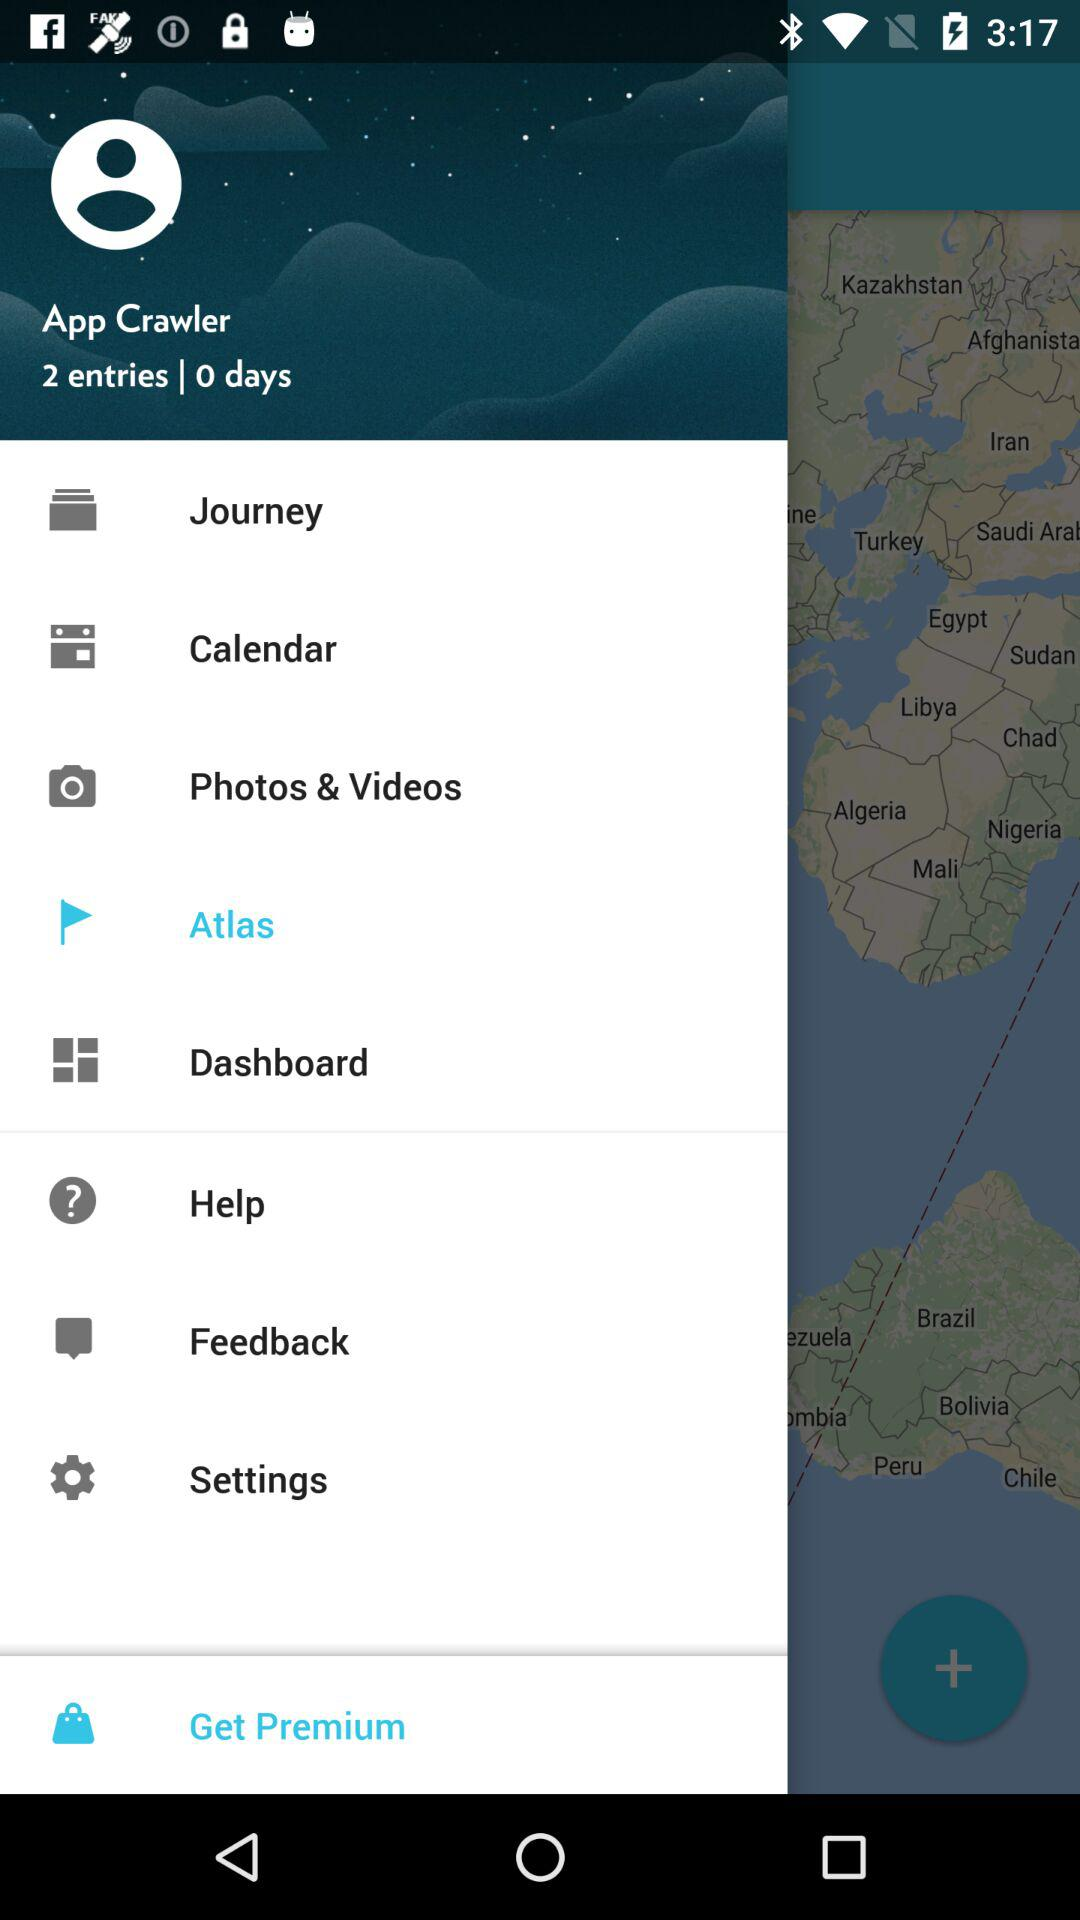What is the name of the user? The name of the user is App Crawler. 